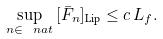<formula> <loc_0><loc_0><loc_500><loc_500>\sup _ { n \in \, \ n a t } \, [ \bar { F } _ { n } ] _ { \text {Lip} } \leq c \, L _ { f } .</formula> 